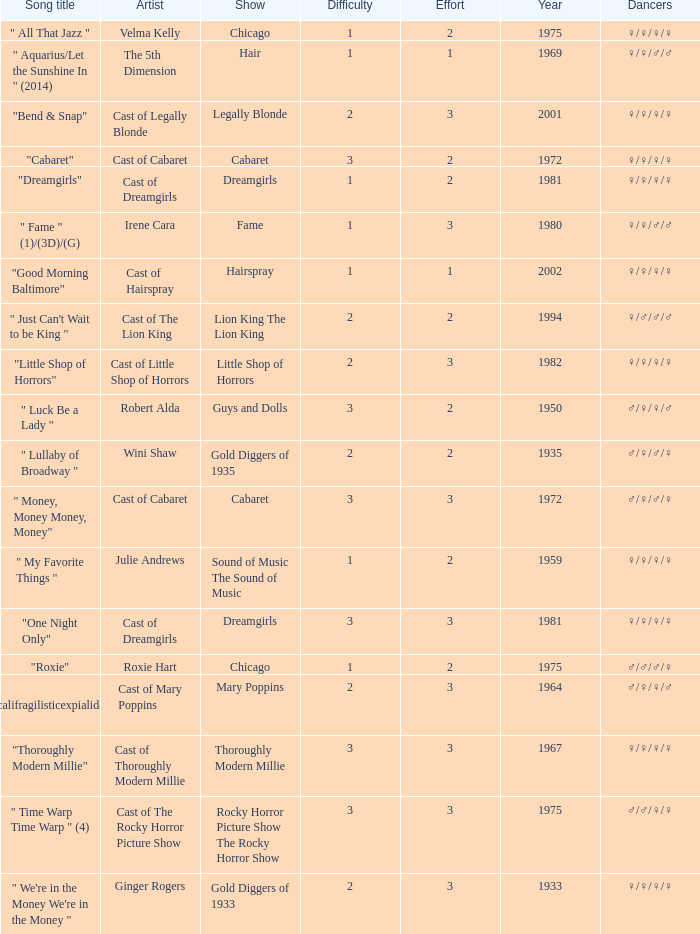How many shows were in 1994? 1.0. 